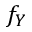Convert formula to latex. <formula><loc_0><loc_0><loc_500><loc_500>f _ { Y }</formula> 